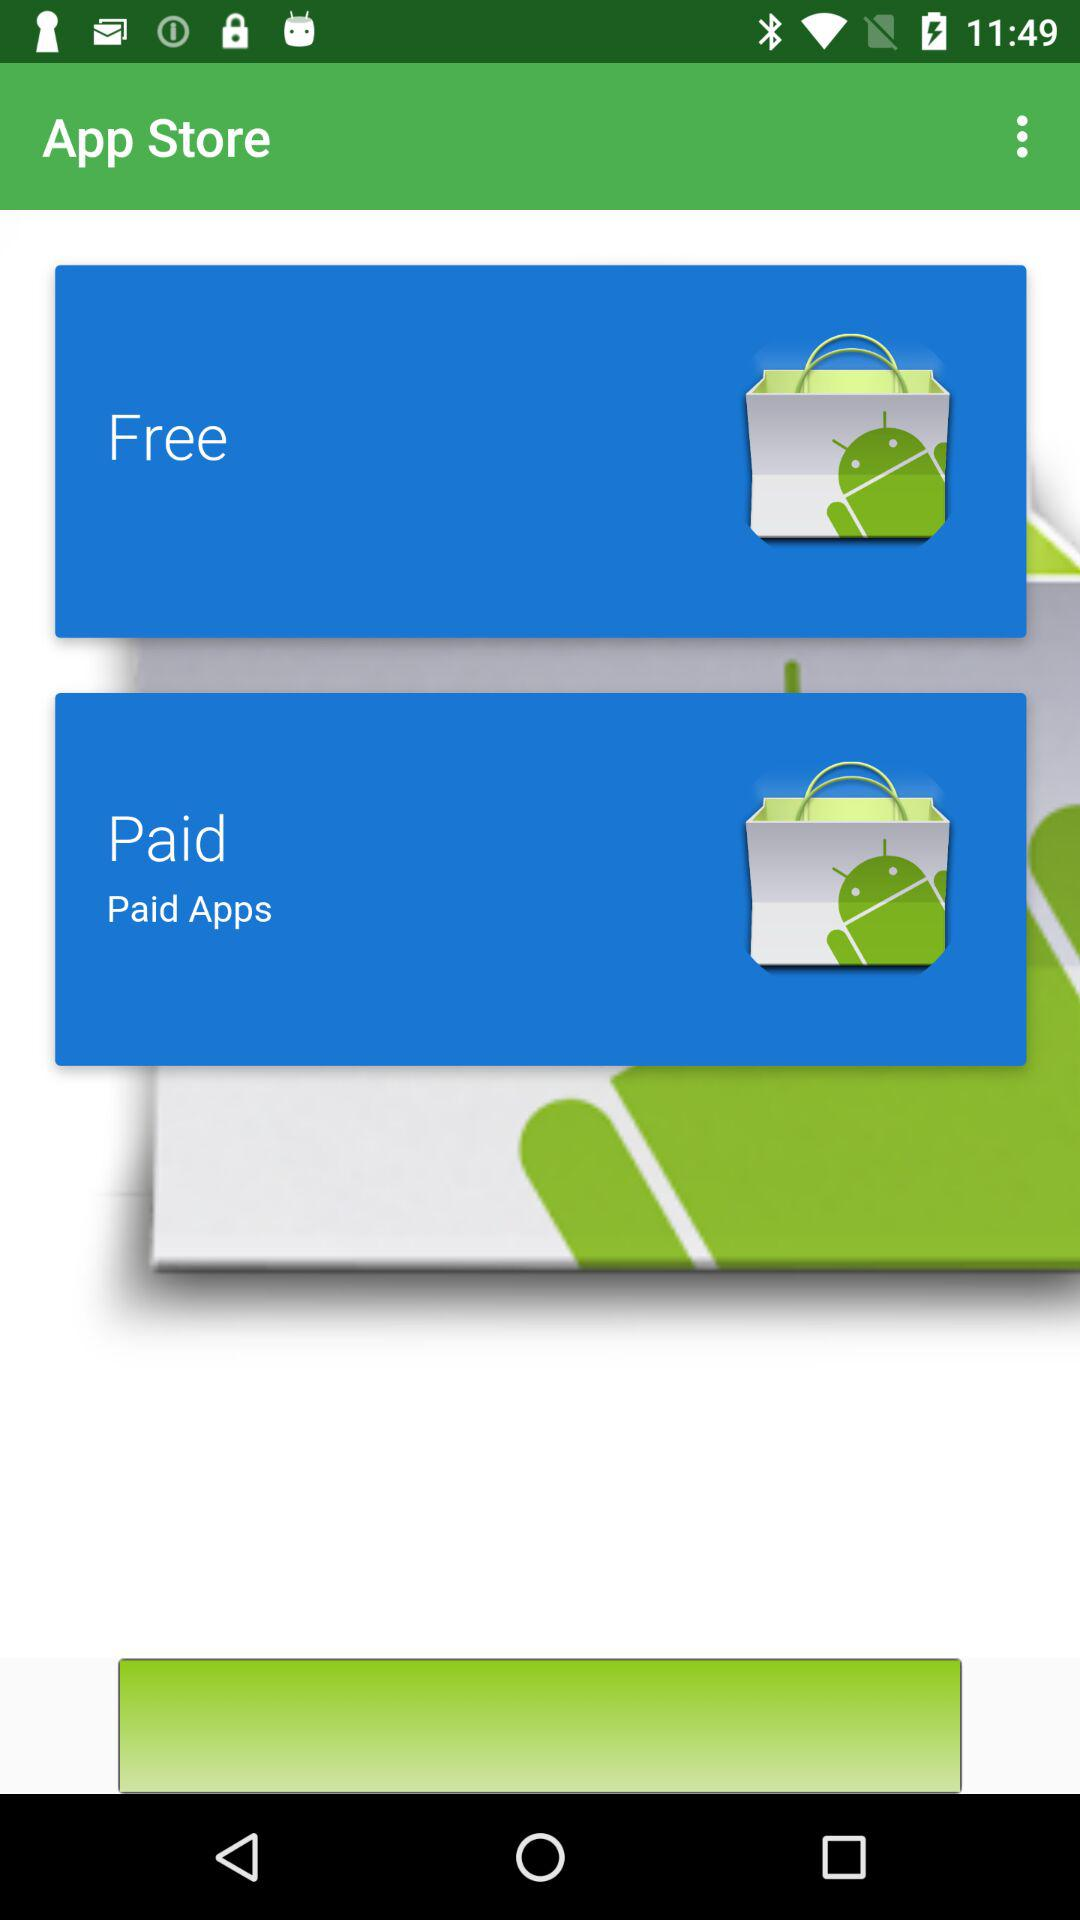What is the application name? The application name is "App Store". 